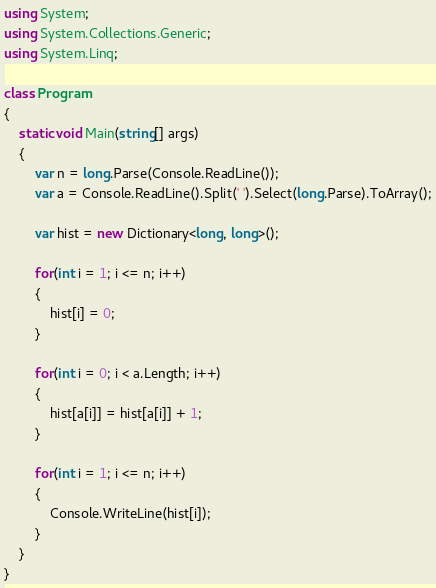<code> <loc_0><loc_0><loc_500><loc_500><_C#_>using System;
using System.Collections.Generic;
using System.Linq;

class Program
{
    static void Main(string[] args)
    {
        var n = long.Parse(Console.ReadLine());
        var a = Console.ReadLine().Split(' ').Select(long.Parse).ToArray();

        var hist = new Dictionary<long, long>();

        for(int i = 1; i <= n; i++)
        {
            hist[i] = 0;
        }

        for(int i = 0; i < a.Length; i++)
        {
            hist[a[i]] = hist[a[i]] + 1;
        }

        for(int i = 1; i <= n; i++)
        {
            Console.WriteLine(hist[i]);
        }
    }
}</code> 